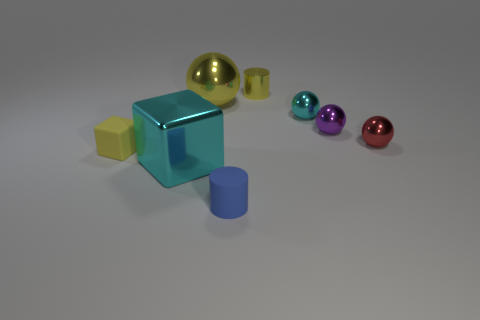Subtract all red balls. How many balls are left? 3 Add 1 matte things. How many objects exist? 9 Subtract all purple spheres. How many spheres are left? 3 Subtract all cylinders. How many objects are left? 6 Subtract 1 spheres. How many spheres are left? 3 Subtract 0 red cylinders. How many objects are left? 8 Subtract all yellow spheres. Subtract all green blocks. How many spheres are left? 3 Subtract all small green matte spheres. Subtract all big metallic objects. How many objects are left? 6 Add 4 tiny matte blocks. How many tiny matte blocks are left? 5 Add 4 yellow metallic spheres. How many yellow metallic spheres exist? 5 